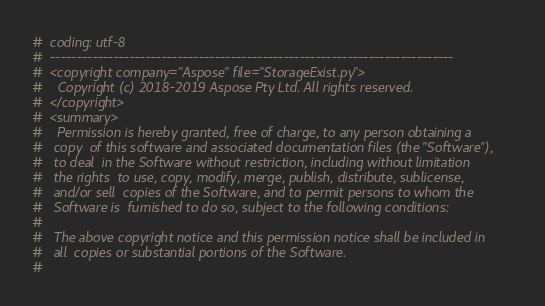<code> <loc_0><loc_0><loc_500><loc_500><_Python_>#  coding: utf-8
#  ----------------------------------------------------------------------------
#  <copyright company="Aspose" file="StorageExist.py">
#    Copyright (c) 2018-2019 Aspose Pty Ltd. All rights reserved.
#  </copyright>
#  <summary>
#    Permission is hereby granted, free of charge, to any person obtaining a
#   copy  of this software and associated documentation files (the "Software"),
#   to deal  in the Software without restriction, including without limitation
#   the rights  to use, copy, modify, merge, publish, distribute, sublicense,
#   and/or sell  copies of the Software, and to permit persons to whom the
#   Software is  furnished to do so, subject to the following conditions:
#
#   The above copyright notice and this permission notice shall be included in
#   all  copies or substantial portions of the Software.
#</code> 